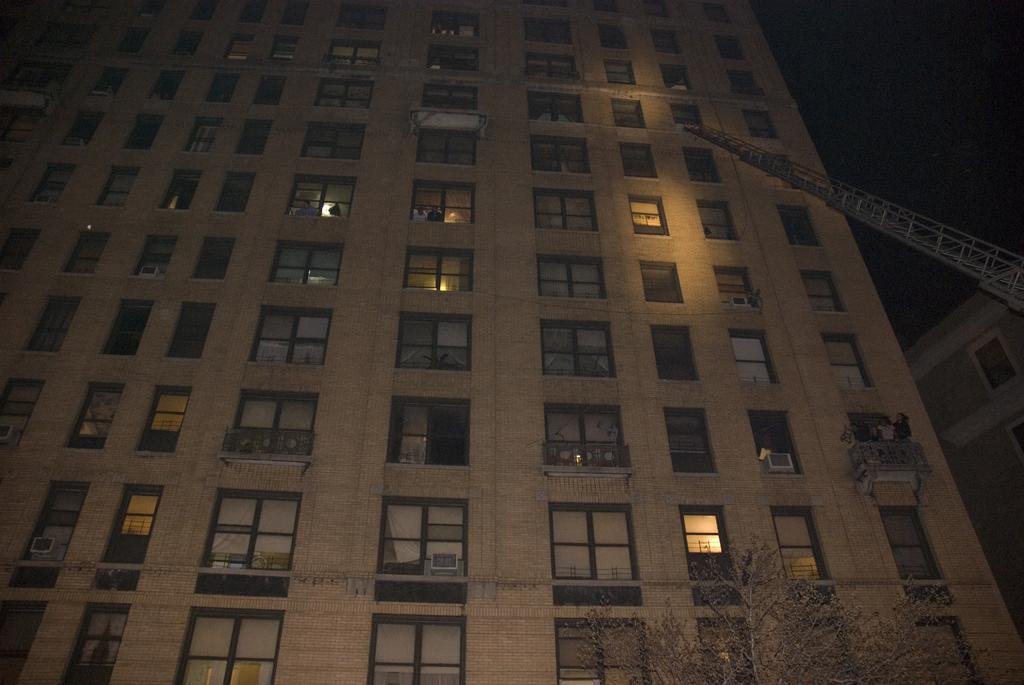What type of structures can be seen in the image? There are buildings in the image. What architectural features are present in the image? There are walls, windows, and railings in the image. Are there any people visible in the image? Yes, there are people in the image. What type of construction equipment can be seen in the image? There is a crane in the image. What type of vegetation is present in the image? There is a tree at the bottom of the image. What is the lighting condition in the top right corner of the image? There is a dark view in the top right corner of the image. Can you tell me how many branches of sugar are present in the image? There is no mention of branches or sugar in the image; it features buildings, walls, windows, railings, people, a crane, a tree, and a dark view in the top right corner. 